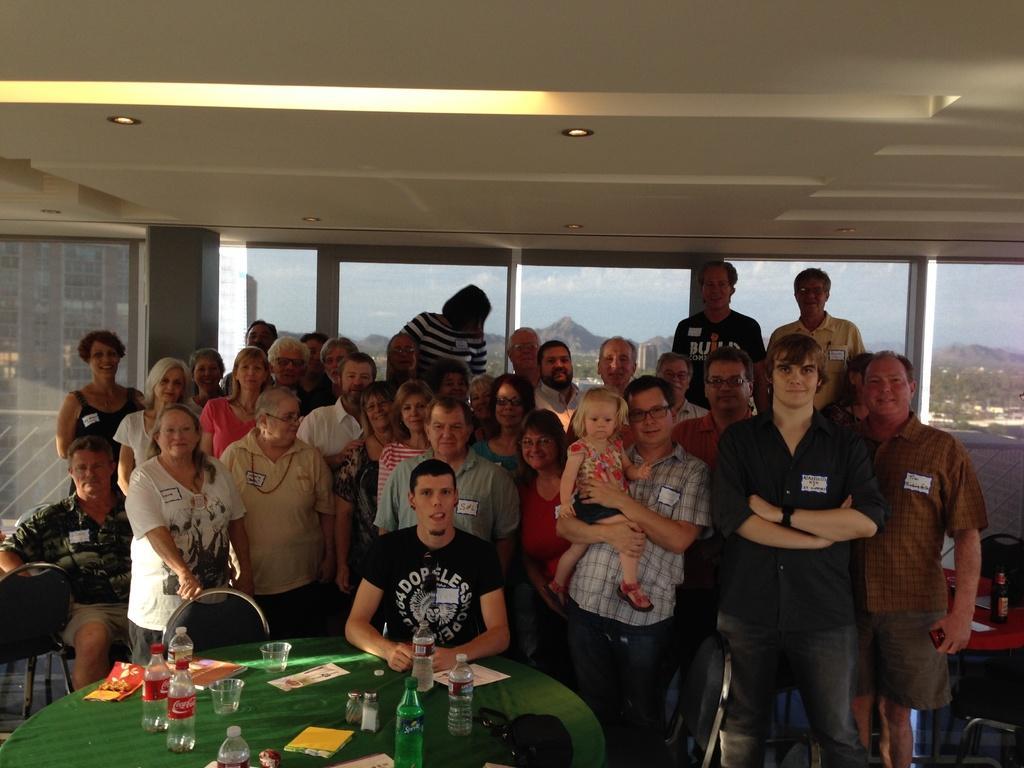Could you give a brief overview of what you see in this image? This picture is of inside. In the foreground there is a table covered with a green cloth and some bottles, a book and some glasses are placed on the top of the table, behind that there is a man wearing black color t-shirt and sitting on the chair. In the center there are group of persons smiling and standing. In the background we can see the window and through the window we can see the outside view. 